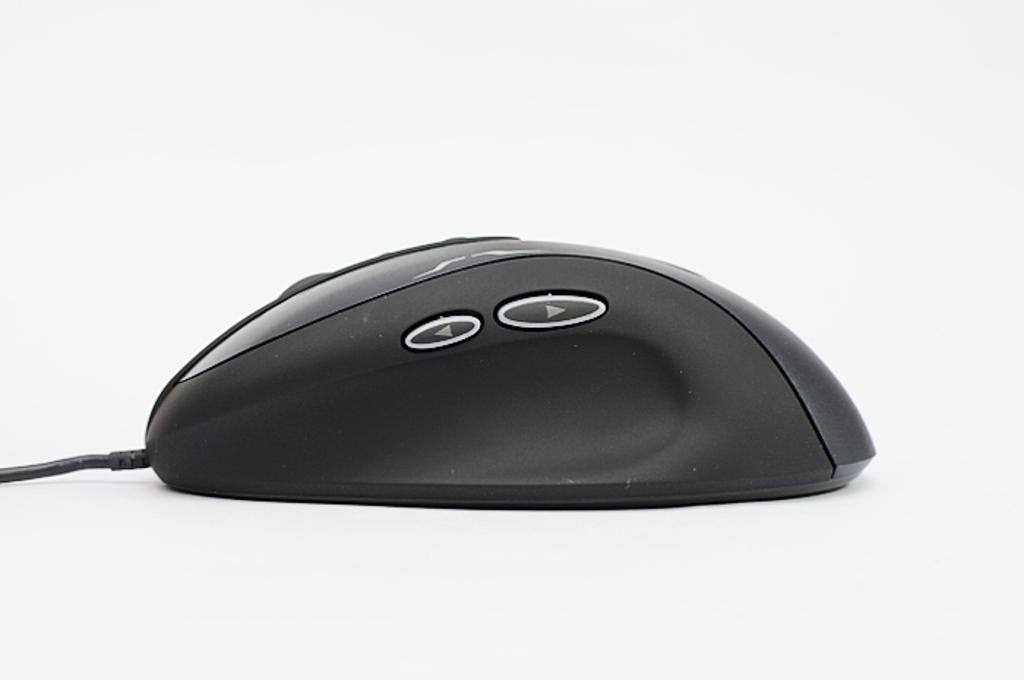What is the main object in the image? There is a computer mouse in the image. Can you describe the computer mouse in more detail? The computer mouse has a wire. What type of voyage is the computer mouse embarking on in the image? The computer mouse is not embarking on a voyage in the image; it is an inanimate object. 